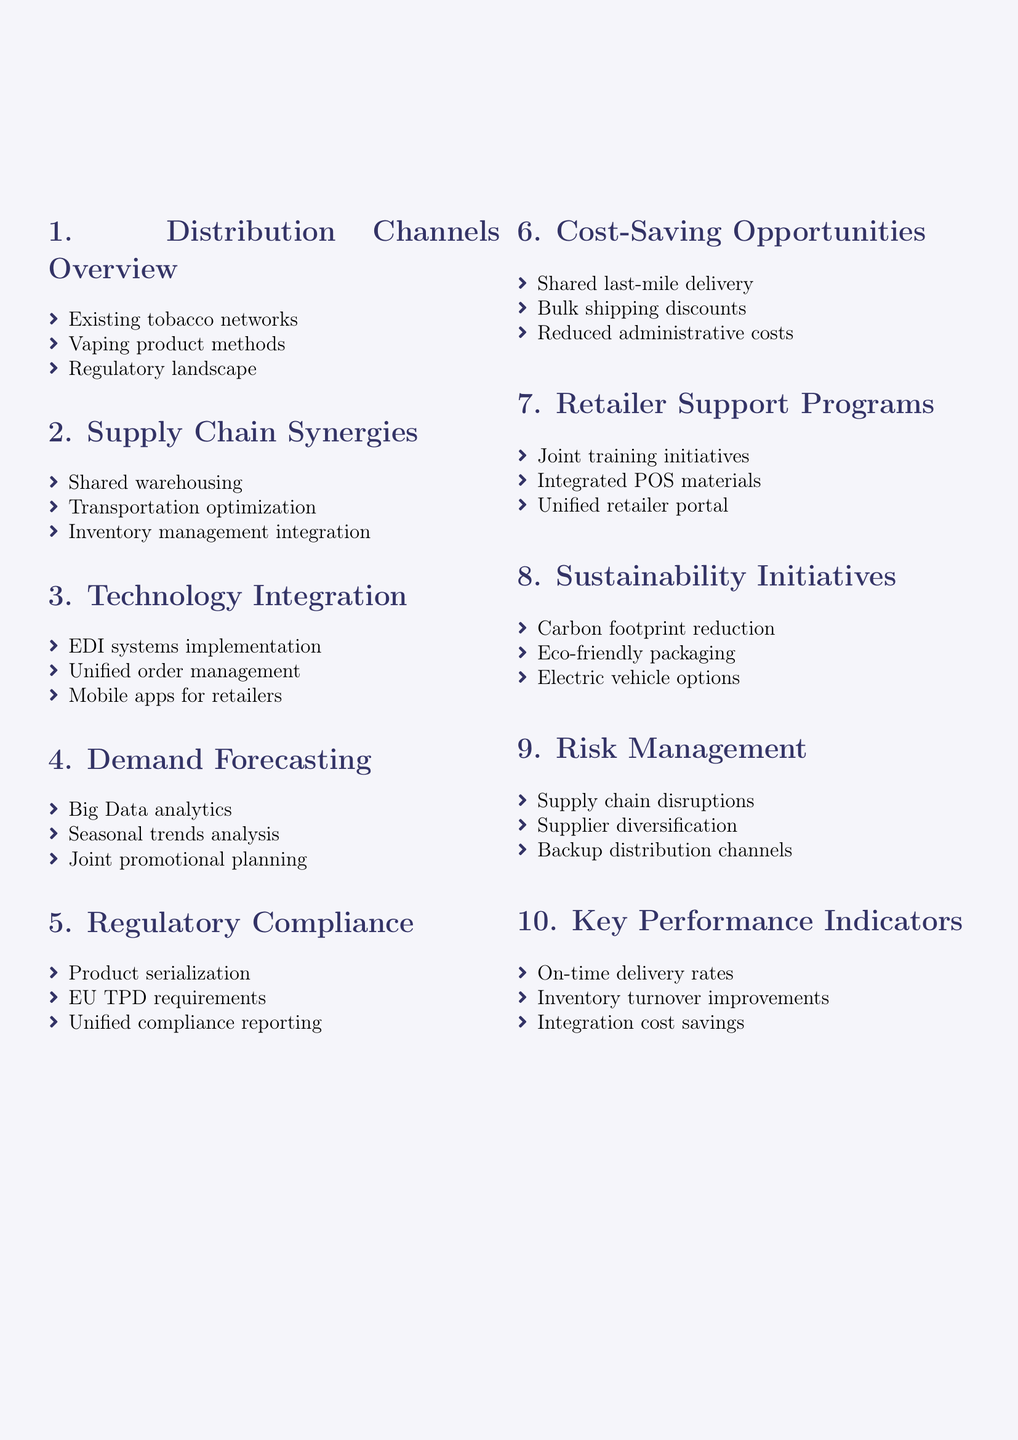What is the first agenda topic? The first agenda topic listed in the document is "Overview of current tobacco and vaping product distribution channels."
Answer: Overview of current tobacco and vaping product distribution channels How many agenda topics are included? The document contains a total of ten agenda topics related to supply chain optimization.
Answer: Ten What technology is mentioned for order management? The document highlights “Salesforce Order Management” as a unified order management platform.
Answer: Salesforce Order Management What are shared opportunities in the supply chain? The document mentions “shared warehousing opportunities” as a potential synergy between tobacco and vaping supply chains.
Answer: Shared warehousing opportunities What are the regulatory requirements mentioned? The document refers to “EU Tobacco Products Directive (TPD) requirements” as a regulatory compliance aspect.
Answer: EU Tobacco Products Directive requirements What is one sustainability initiative proposed? The document suggests “reducing carbon footprint through optimized logistics” as a sustainability initiative.
Answer: Reducing carbon footprint through optimized logistics What is a KPI related to delivery? “On-time delivery rates for combined shipments” is specified as a key performance indicator regarding delivery.
Answer: On-time delivery rates Which company is mentioned for transportation optimization? The document suggests partnering with “UPS” or “FedEx” for transportation optimization.
Answer: UPS or FedEx What type of analysis is leveraged for demand forecasting? The document mentions utilizing “Big Data analytics” for collaborative demand forecasting.
Answer: Big Data analytics What is one way to achieve cost savings in distribution? “Shared last-mile delivery options” are proposed as a way to achieve cost savings through integrated distribution.
Answer: Shared last-mile delivery options 